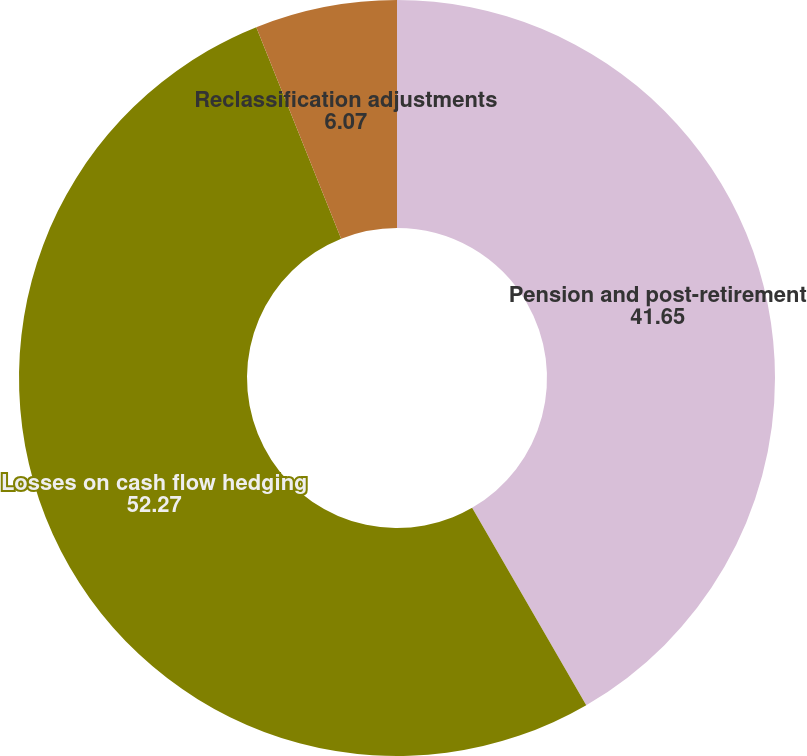<chart> <loc_0><loc_0><loc_500><loc_500><pie_chart><fcel>Pension and post-retirement<fcel>Losses on cash flow hedging<fcel>Reclassification adjustments<nl><fcel>41.65%<fcel>52.27%<fcel>6.07%<nl></chart> 